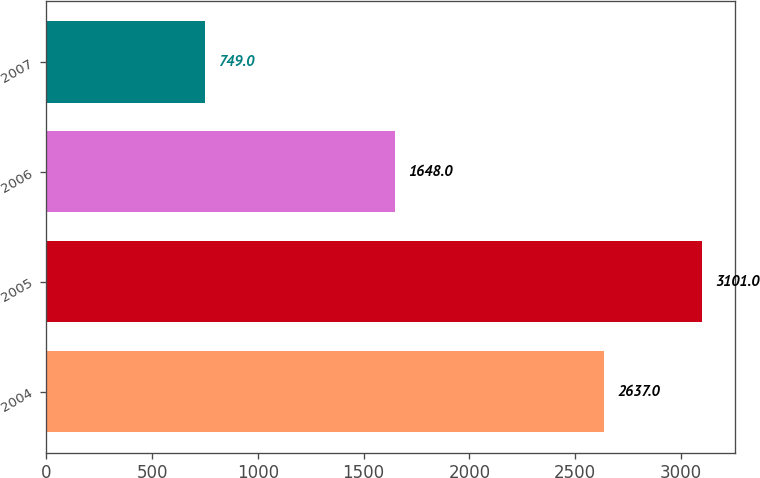Convert chart to OTSL. <chart><loc_0><loc_0><loc_500><loc_500><bar_chart><fcel>2004<fcel>2005<fcel>2006<fcel>2007<nl><fcel>2637<fcel>3101<fcel>1648<fcel>749<nl></chart> 